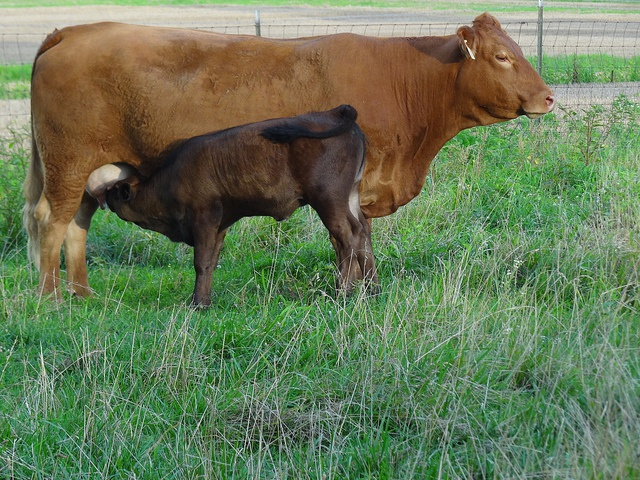Describe the objects in this image and their specific colors. I can see cow in lightgreen, maroon, gray, and brown tones and cow in lightgreen, black, gray, and maroon tones in this image. 